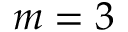Convert formula to latex. <formula><loc_0><loc_0><loc_500><loc_500>m = 3</formula> 